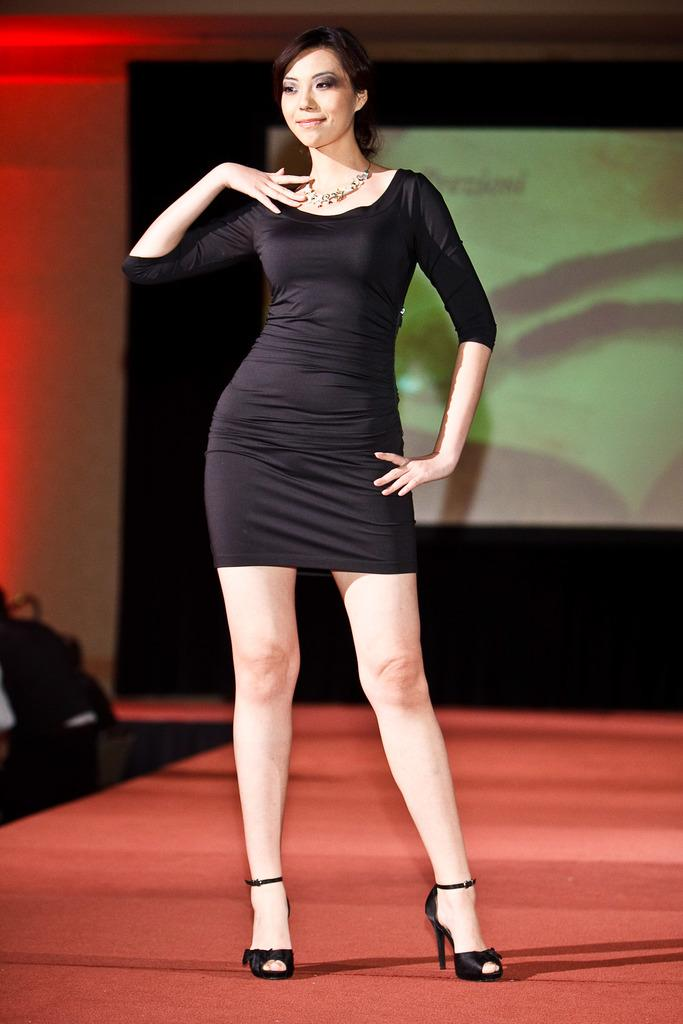Who is in the image? There is a woman in the image. What is the woman wearing? The woman is wearing a black dress, a necklace, and black heels. What can be seen in the background of the image? There is a projector display in the background, and there is a red light on the left side of the background. What type of ball is being used by the woman in the image? There is no ball present in the image. What is the woman using to carry her arrows in the image? There are no arrows or quivers present in the image. 